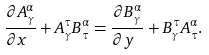<formula> <loc_0><loc_0><loc_500><loc_500>\frac { \partial A ^ { \alpha } _ { \gamma } } { \partial x \ } + A ^ { \tau } _ { \gamma } B _ { \tau } ^ { \alpha } = \frac { \partial B ^ { \alpha } _ { \gamma } } { \partial y \ } + B ^ { \tau } _ { \gamma } A _ { \tau } ^ { \alpha } .</formula> 